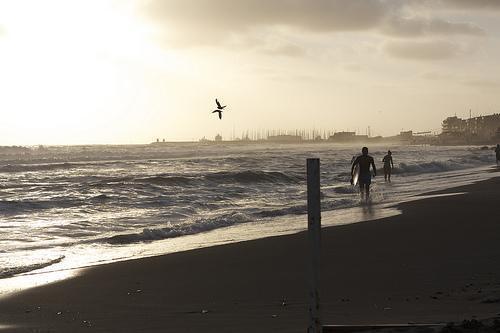How many people are in the image?
Give a very brief answer. 2. 